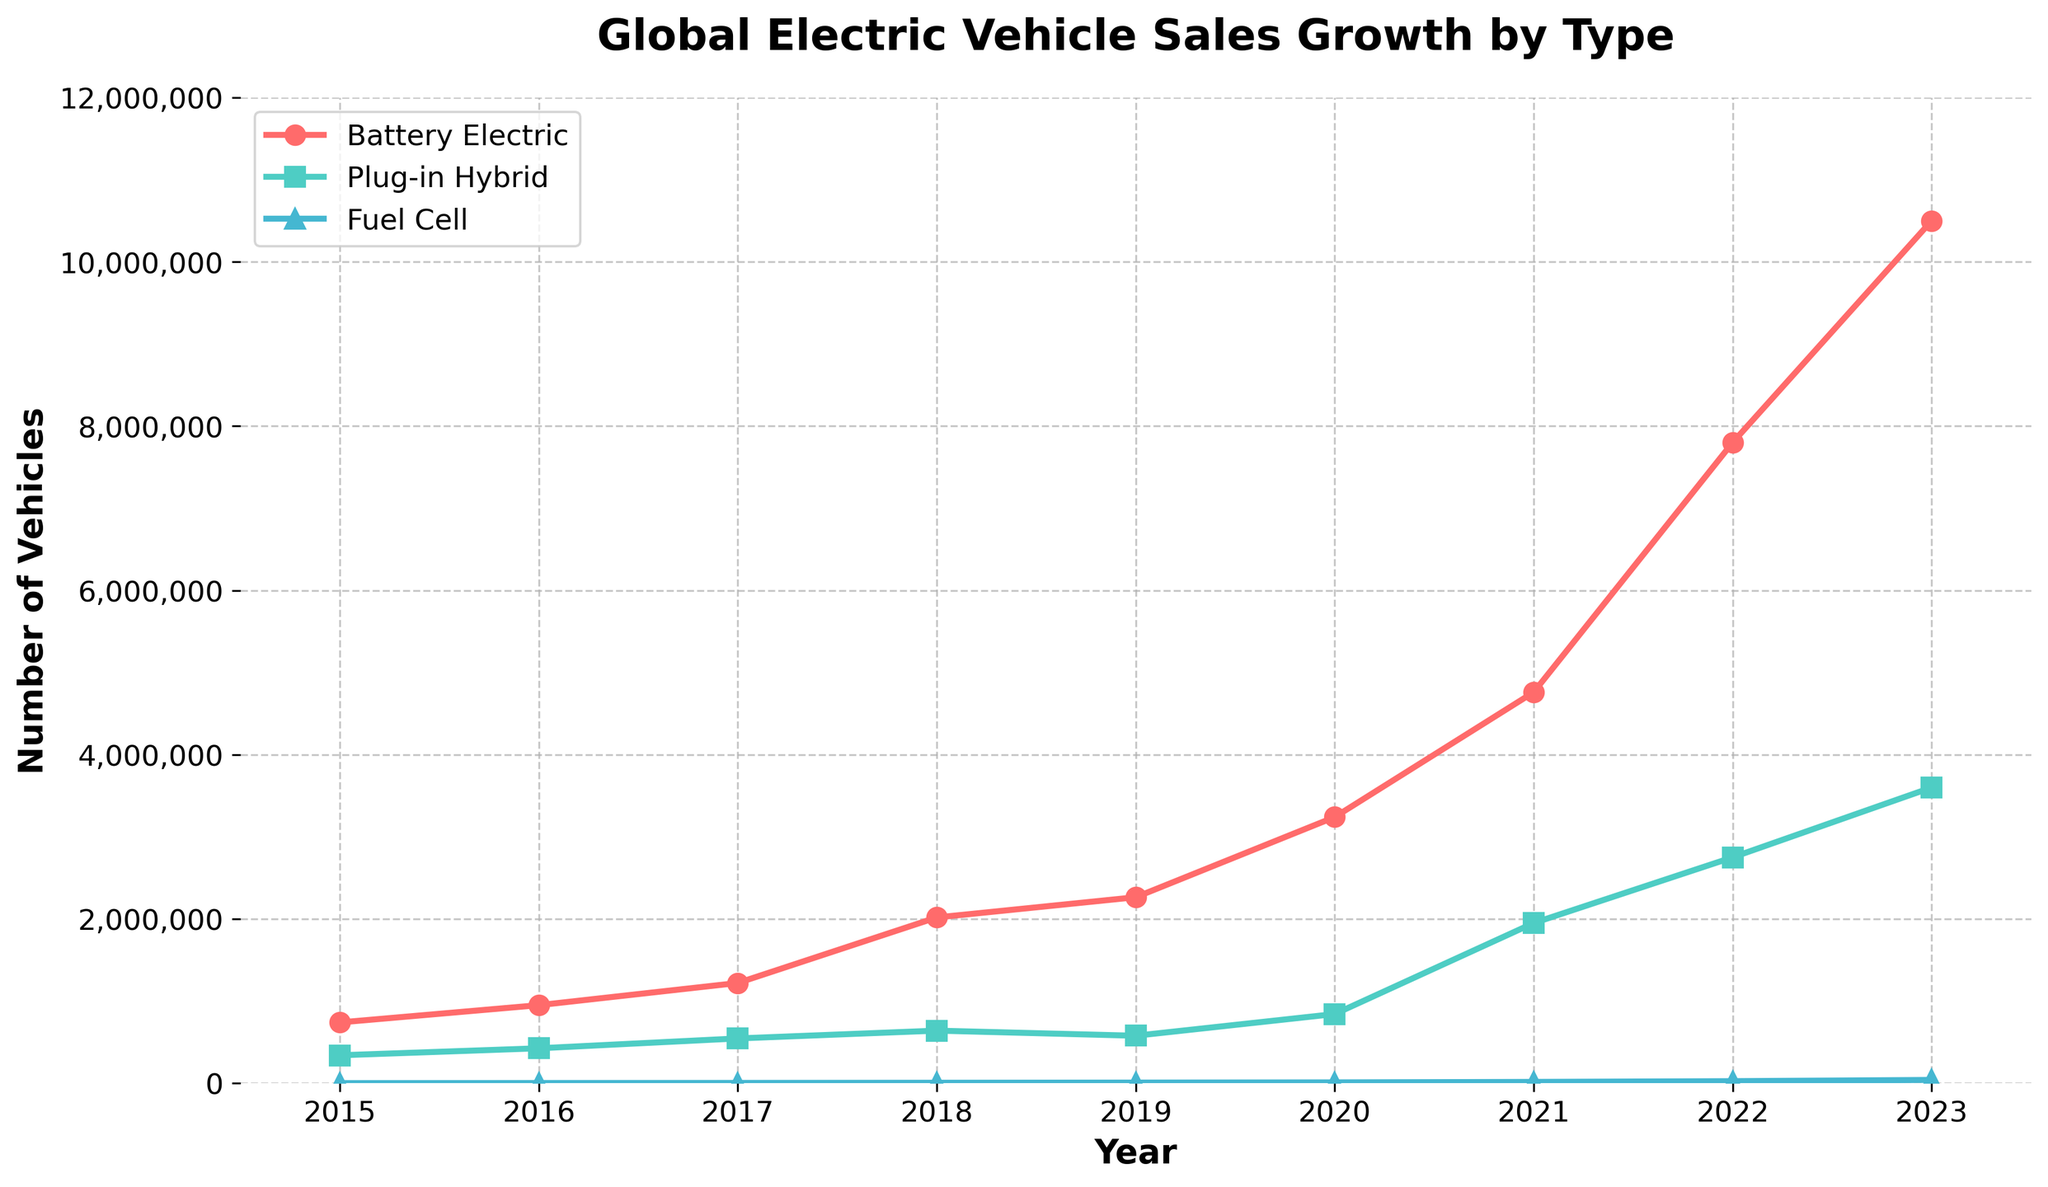What is the trend in the sales of Battery Electric Vehicles from 2015 to 2023? The line for Battery Electric Vehicles shows an increasing trend from 2015 to 2023. Starting at 740,000 in 2015, it reaches 10,500,000 in 2023.
Answer: Increasing Which year saw the highest number of Plug-in Hybrid Electric Vehicles sold? To find this, look for the highest point on the line representing Plug-in Hybrid Electric Vehicles. The highest point is in 2023 with 3,600,000 vehicles sold.
Answer: 2023 How many more Plug-in Hybrid Electric Vehicles were sold in 2023 compared to 2015? Subtract the number of Plug-in Hybrid Electric Vehicles sold in 2015 (340,000) from the number sold in 2023 (3,600,000): 3,600,000 - 340,000 = 3,260,000.
Answer: 3,260,000 In which year did Fuel Cell Electric Vehicles sales first surpass 10,000 units? Identify where the line representing Fuel Cell Electric Vehicles crosses the 10,000 mark. This happens in 2020.
Answer: 2020 What is the total number of Battery Electric Vehicles and Plug-in Hybrid Electric Vehicles sold in 2021? Add the number of Battery Electric Vehicles (4,760,000) and Plug-in Hybrid Electric Vehicles (1,950,000) sold in 2021: 4,760,000 + 1,950,000 = 6,710,000.
Answer: 6,710,000 Between 2019 and 2021, which year had the highest number of Fuel Cell Electric Vehicles sold? Compare the sales of Fuel Cell Electric Vehicles in 2019 (7,500), 2020 (10,100), and 2021 (15,800). The highest number is in 2021.
Answer: 2021 By how much did Battery Electric Vehicle sales increase from 2020 to 2022? Subtract the number of Battery Electric Vehicles sold in 2020 (3,240,000) from the number sold in 2022 (7,800,000): 7,800,000 - 3,240,000 = 4,560,000.
Answer: 4,560,000 What visual attributes are used to distinguish the three types of vehicles in the chart? The chart uses different markers and colors for each vehicle type: circles and red for Battery Electric Vehicles, squares and green for Plug-in Hybrid Electric Vehicles, and triangles and blue for Fuel Cell Electric Vehicles.
Answer: Markers and colors Which vehicle type had the least growth from 2015 to 2023? Compare the starting and ending sales for each vehicle type over the period. Fuel Cell Electric Vehicles starts at 1,000 in 2015 and ends at 40,000 in 2023, showing the smallest numerical growth.
Answer: Fuel Cell Electric Vehicles 